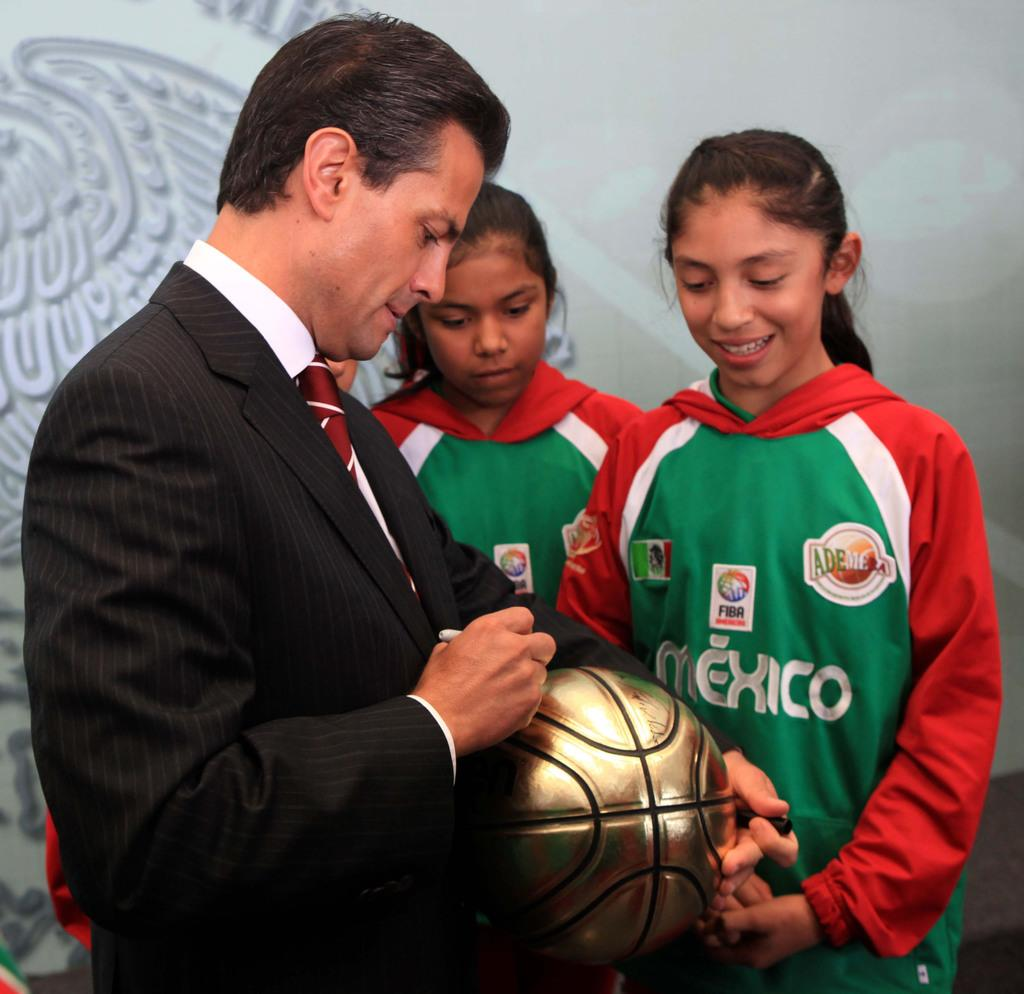<image>
Offer a succinct explanation of the picture presented. A man signing a gold soccer ball next to a girl wearing a red, white and green hoodie that says Mexico 